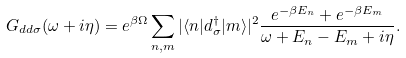Convert formula to latex. <formula><loc_0><loc_0><loc_500><loc_500>G _ { d d \sigma } ( \omega + i \eta ) = e ^ { \beta \Omega } \sum _ { n , m } | \langle n | d _ { \sigma } ^ { \dagger } | m \rangle | ^ { 2 } \frac { e ^ { - \beta E _ { n } } + e ^ { - \beta E _ { m } } } { \omega + E _ { n } - E _ { m } + i \eta } .</formula> 